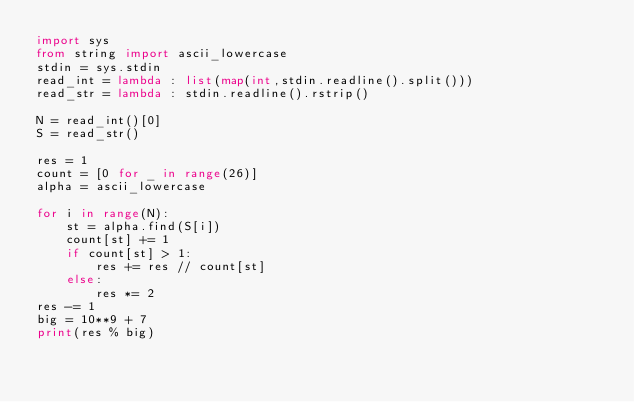Convert code to text. <code><loc_0><loc_0><loc_500><loc_500><_Python_>import sys
from string import ascii_lowercase
stdin = sys.stdin
read_int = lambda : list(map(int,stdin.readline().split()))
read_str = lambda : stdin.readline().rstrip()

N = read_int()[0]
S = read_str()

res = 1
count = [0 for _ in range(26)]
alpha = ascii_lowercase

for i in range(N):
    st = alpha.find(S[i])
    count[st] += 1
    if count[st] > 1:
        res += res // count[st]
    else:
        res *= 2
res -= 1
big = 10**9 + 7
print(res % big)
</code> 